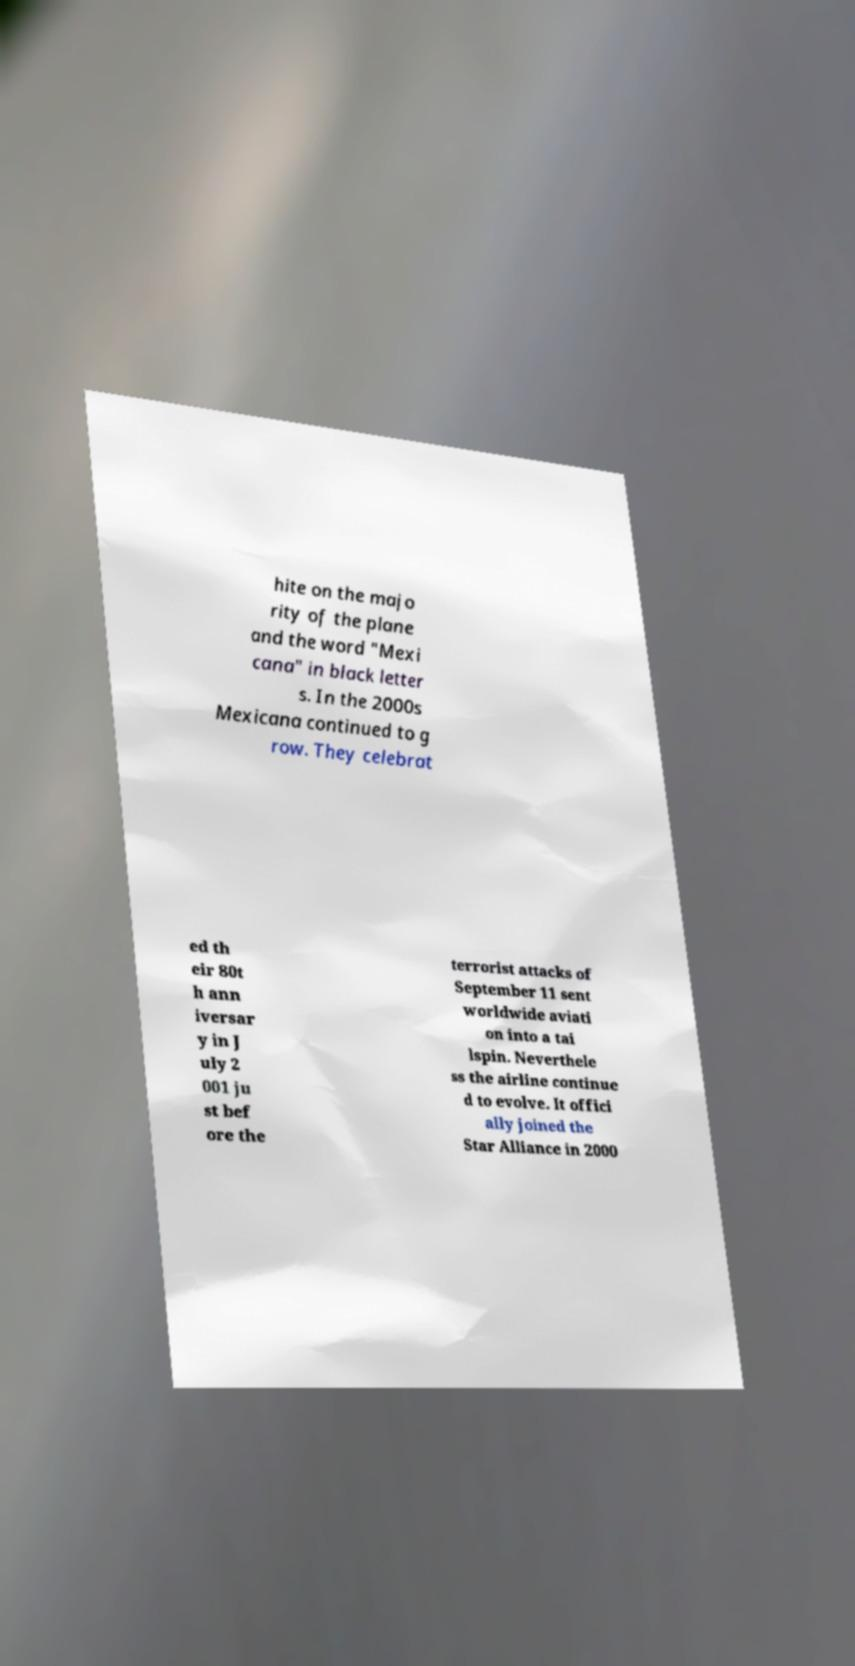Please identify and transcribe the text found in this image. hite on the majo rity of the plane and the word "Mexi cana" in black letter s. In the 2000s Mexicana continued to g row. They celebrat ed th eir 80t h ann iversar y in J uly 2 001 ju st bef ore the terrorist attacks of September 11 sent worldwide aviati on into a tai lspin. Neverthele ss the airline continue d to evolve. It offici ally joined the Star Alliance in 2000 